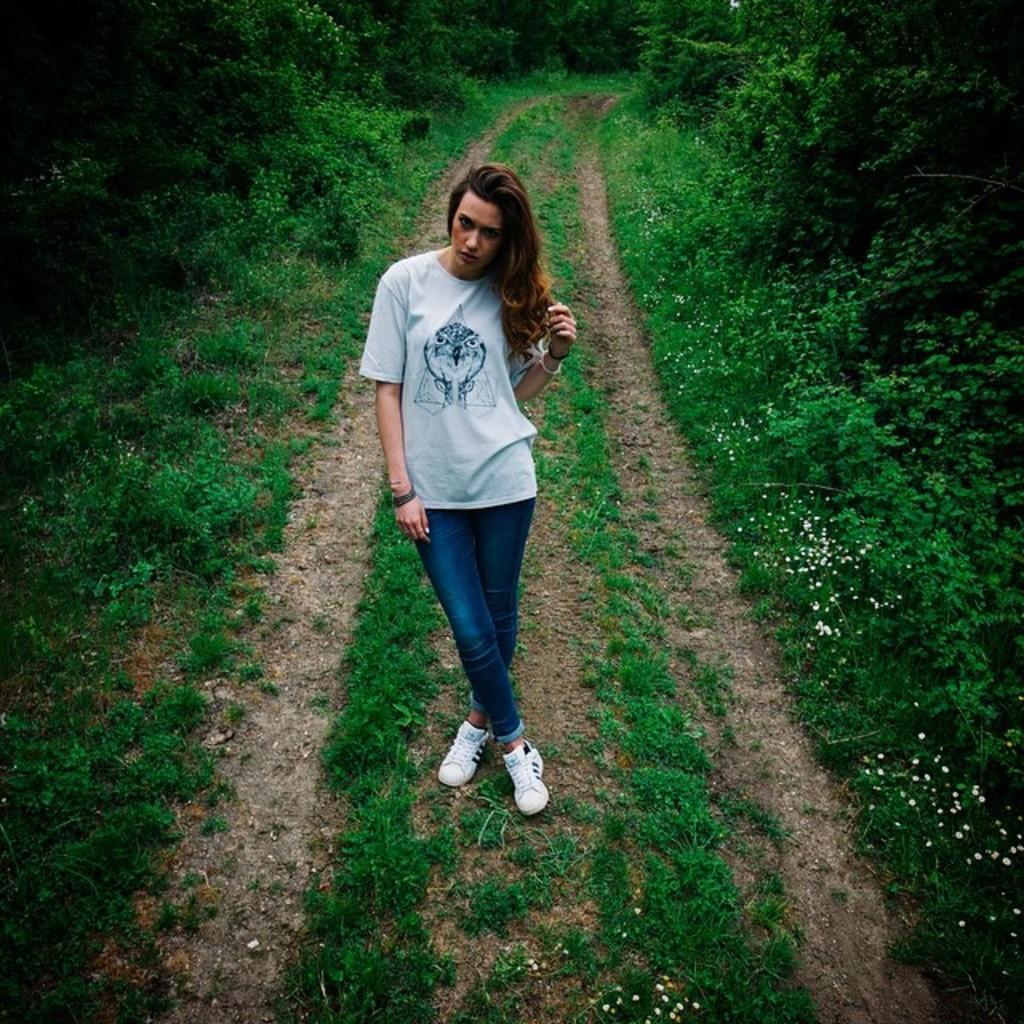Describe this image in one or two sentences. In this picture we can see a woman in the white t shirt is standing on the path and behind the women there are plants and trees. 